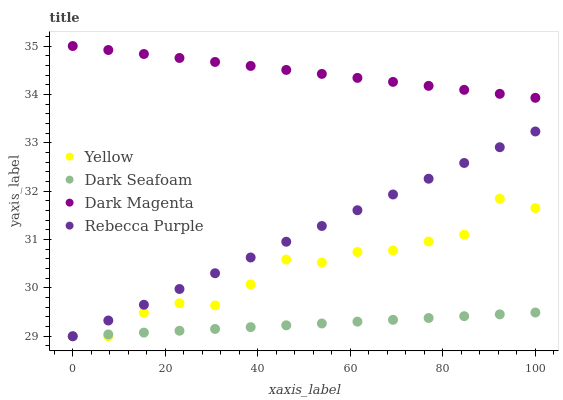Does Dark Seafoam have the minimum area under the curve?
Answer yes or no. Yes. Does Dark Magenta have the maximum area under the curve?
Answer yes or no. Yes. Does Yellow have the minimum area under the curve?
Answer yes or no. No. Does Yellow have the maximum area under the curve?
Answer yes or no. No. Is Dark Seafoam the smoothest?
Answer yes or no. Yes. Is Yellow the roughest?
Answer yes or no. Yes. Is Dark Magenta the smoothest?
Answer yes or no. No. Is Dark Magenta the roughest?
Answer yes or no. No. Does Dark Seafoam have the lowest value?
Answer yes or no. Yes. Does Dark Magenta have the lowest value?
Answer yes or no. No. Does Dark Magenta have the highest value?
Answer yes or no. Yes. Does Yellow have the highest value?
Answer yes or no. No. Is Yellow less than Dark Magenta?
Answer yes or no. Yes. Is Dark Magenta greater than Dark Seafoam?
Answer yes or no. Yes. Does Yellow intersect Dark Seafoam?
Answer yes or no. Yes. Is Yellow less than Dark Seafoam?
Answer yes or no. No. Is Yellow greater than Dark Seafoam?
Answer yes or no. No. Does Yellow intersect Dark Magenta?
Answer yes or no. No. 